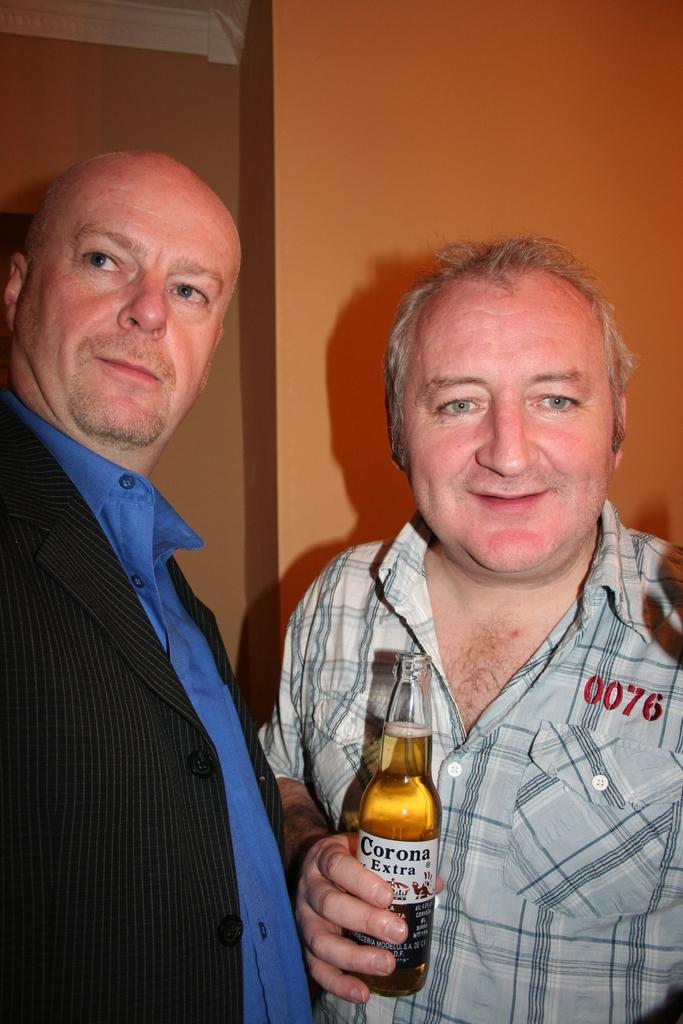How many people are present in the image? There are two people in the image. What is one person wearing? One person is wearing a blazer. What is the other person holding? The other person is holding a wine bottle. What type of sail can be seen in the image? There is no sail present in the image. How many family members are visible in the image? The number of family members cannot be determined from the image, as only two people are present, and their relationship is not specified. 